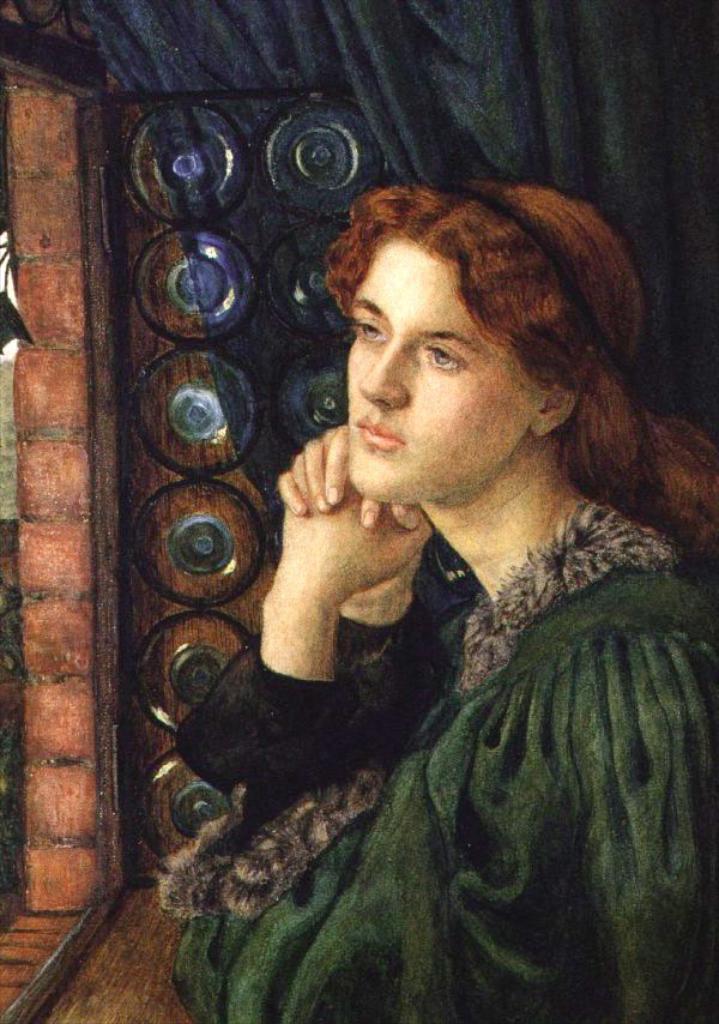Can you describe this image briefly? This picture consists of a painting. 